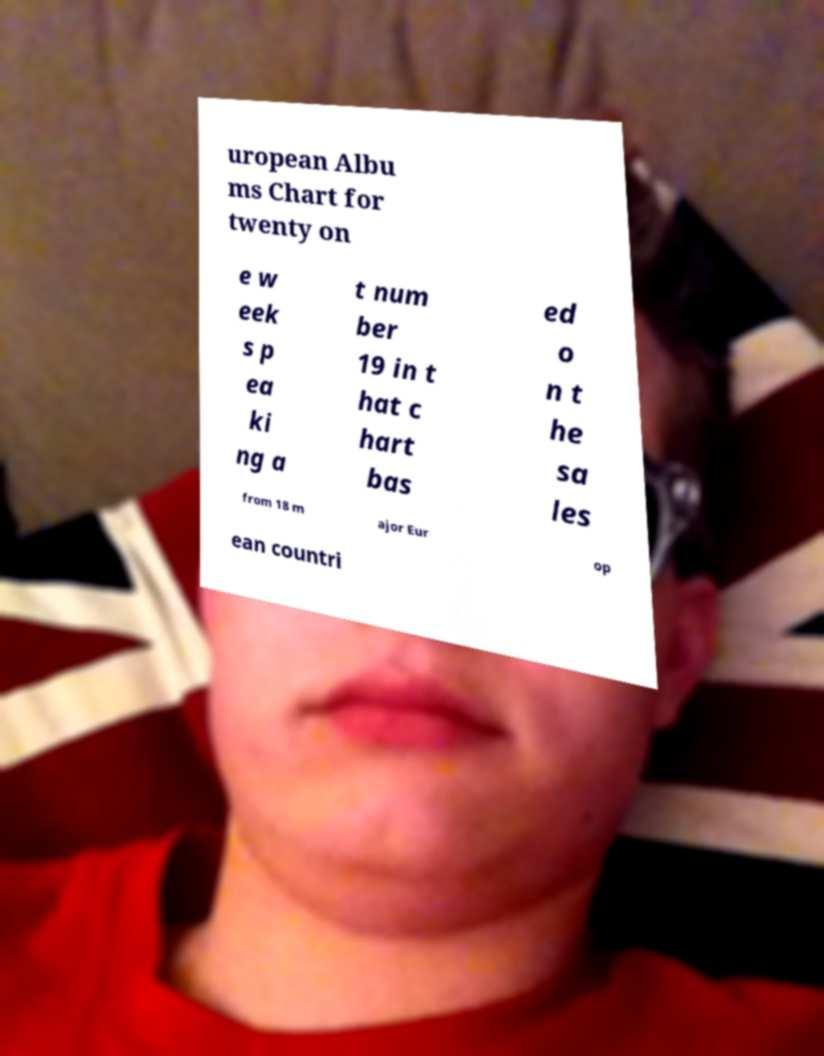Could you extract and type out the text from this image? uropean Albu ms Chart for twenty on e w eek s p ea ki ng a t num ber 19 in t hat c hart bas ed o n t he sa les from 18 m ajor Eur op ean countri 